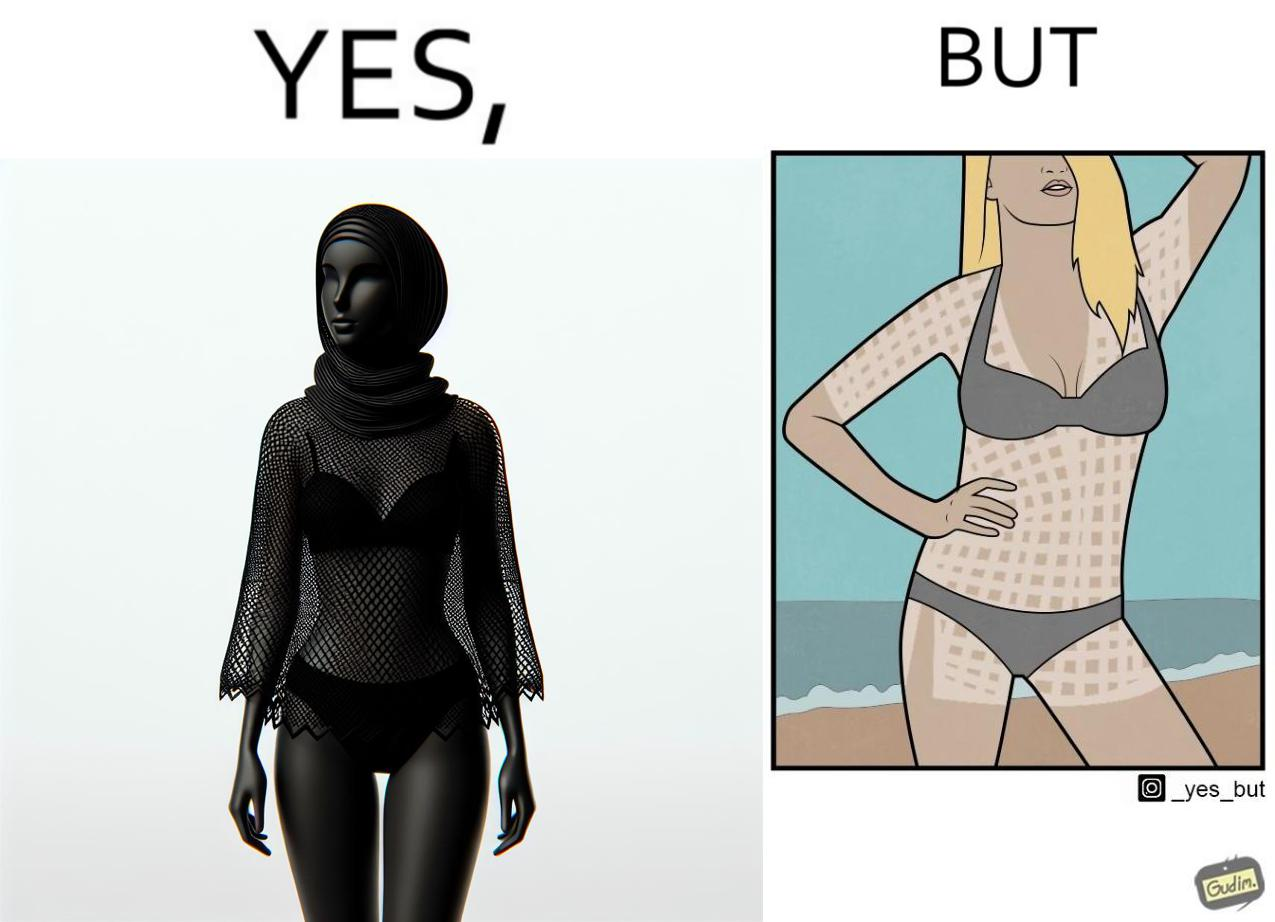Compare the left and right sides of this image. In the left part of the image: a woman wearing a netted top over bikini posing for some photo at beach In the right part of the image: a woman wearing bikini, with tanned body in some spots, posing for some photo at beach 